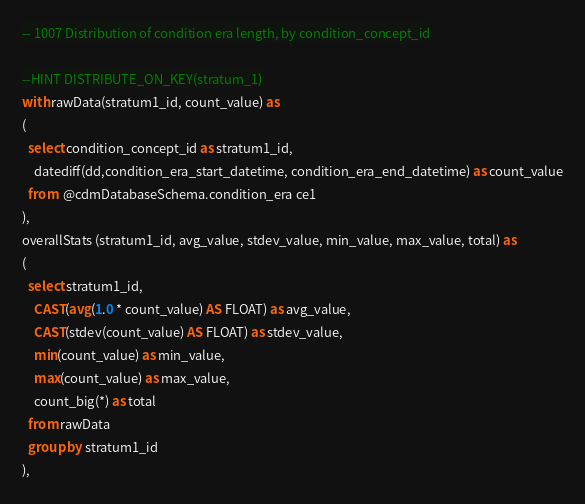<code> <loc_0><loc_0><loc_500><loc_500><_SQL_>-- 1007	Distribution of condition era length, by condition_concept_id

--HINT DISTRIBUTE_ON_KEY(stratum_1)
with rawData(stratum1_id, count_value) as
(
  select condition_concept_id as stratum1_id,
    datediff(dd,condition_era_start_datetime, condition_era_end_datetime) as count_value
  from  @cdmDatabaseSchema.condition_era ce1
),
overallStats (stratum1_id, avg_value, stdev_value, min_value, max_value, total) as
(
  select stratum1_id, 
    CAST(avg(1.0 * count_value) AS FLOAT) as avg_value,
    CAST(stdev(count_value) AS FLOAT) as stdev_value,
    min(count_value) as min_value,
    max(count_value) as max_value,
    count_big(*) as total
  from rawData
  group by stratum1_id
),</code> 